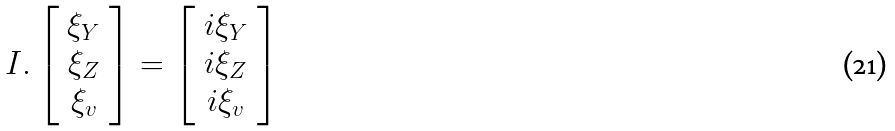<formula> <loc_0><loc_0><loc_500><loc_500>I . \left [ \begin{array} { c } { { \xi _ { Y } } } \\ { { \xi _ { Z } } } \\ { { \xi _ { v } } } \end{array} \right ] = \left [ \begin{array} { c } { { i \xi _ { Y } } } \\ { { i \xi _ { Z } } } \\ { { i \xi _ { v } } } \end{array} \right ]</formula> 